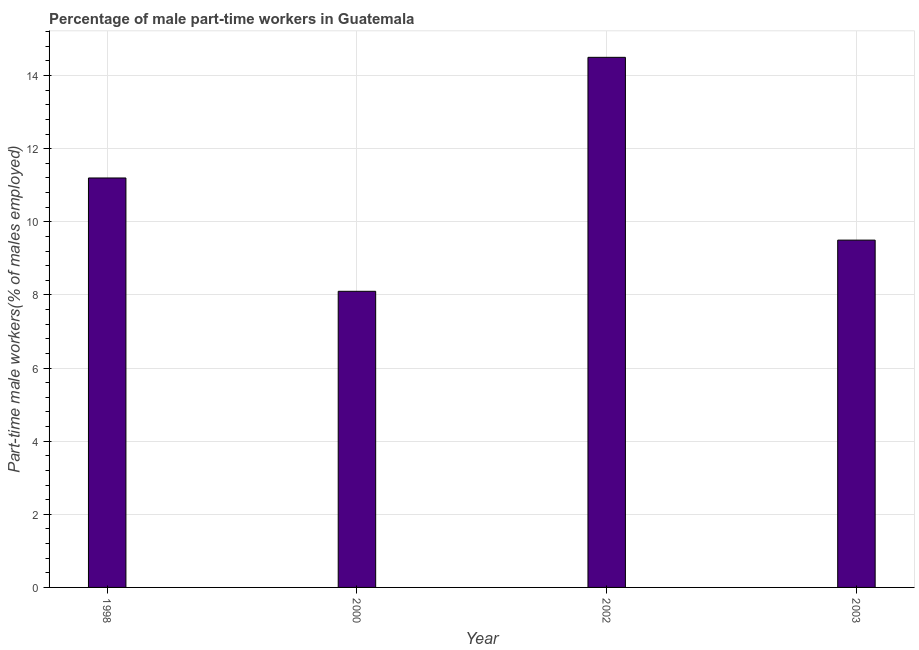What is the title of the graph?
Your answer should be compact. Percentage of male part-time workers in Guatemala. What is the label or title of the Y-axis?
Offer a terse response. Part-time male workers(% of males employed). Across all years, what is the minimum percentage of part-time male workers?
Your answer should be very brief. 8.1. In which year was the percentage of part-time male workers maximum?
Make the answer very short. 2002. In which year was the percentage of part-time male workers minimum?
Your answer should be very brief. 2000. What is the sum of the percentage of part-time male workers?
Give a very brief answer. 43.3. What is the difference between the percentage of part-time male workers in 1998 and 2002?
Make the answer very short. -3.3. What is the average percentage of part-time male workers per year?
Keep it short and to the point. 10.82. What is the median percentage of part-time male workers?
Offer a very short reply. 10.35. In how many years, is the percentage of part-time male workers greater than 1.2 %?
Provide a short and direct response. 4. What is the ratio of the percentage of part-time male workers in 1998 to that in 2000?
Provide a short and direct response. 1.38. Is the percentage of part-time male workers in 1998 less than that in 2003?
Provide a succinct answer. No. Is the difference between the percentage of part-time male workers in 2002 and 2003 greater than the difference between any two years?
Ensure brevity in your answer.  No. Is the sum of the percentage of part-time male workers in 2000 and 2003 greater than the maximum percentage of part-time male workers across all years?
Your response must be concise. Yes. What is the difference between the highest and the lowest percentage of part-time male workers?
Provide a succinct answer. 6.4. How many bars are there?
Your answer should be very brief. 4. What is the Part-time male workers(% of males employed) in 1998?
Provide a short and direct response. 11.2. What is the Part-time male workers(% of males employed) of 2000?
Keep it short and to the point. 8.1. What is the difference between the Part-time male workers(% of males employed) in 1998 and 2000?
Provide a succinct answer. 3.1. What is the difference between the Part-time male workers(% of males employed) in 1998 and 2002?
Your answer should be compact. -3.3. What is the difference between the Part-time male workers(% of males employed) in 1998 and 2003?
Offer a terse response. 1.7. What is the difference between the Part-time male workers(% of males employed) in 2000 and 2002?
Offer a terse response. -6.4. What is the difference between the Part-time male workers(% of males employed) in 2000 and 2003?
Provide a short and direct response. -1.4. What is the ratio of the Part-time male workers(% of males employed) in 1998 to that in 2000?
Ensure brevity in your answer.  1.38. What is the ratio of the Part-time male workers(% of males employed) in 1998 to that in 2002?
Offer a very short reply. 0.77. What is the ratio of the Part-time male workers(% of males employed) in 1998 to that in 2003?
Make the answer very short. 1.18. What is the ratio of the Part-time male workers(% of males employed) in 2000 to that in 2002?
Your answer should be compact. 0.56. What is the ratio of the Part-time male workers(% of males employed) in 2000 to that in 2003?
Keep it short and to the point. 0.85. What is the ratio of the Part-time male workers(% of males employed) in 2002 to that in 2003?
Provide a short and direct response. 1.53. 